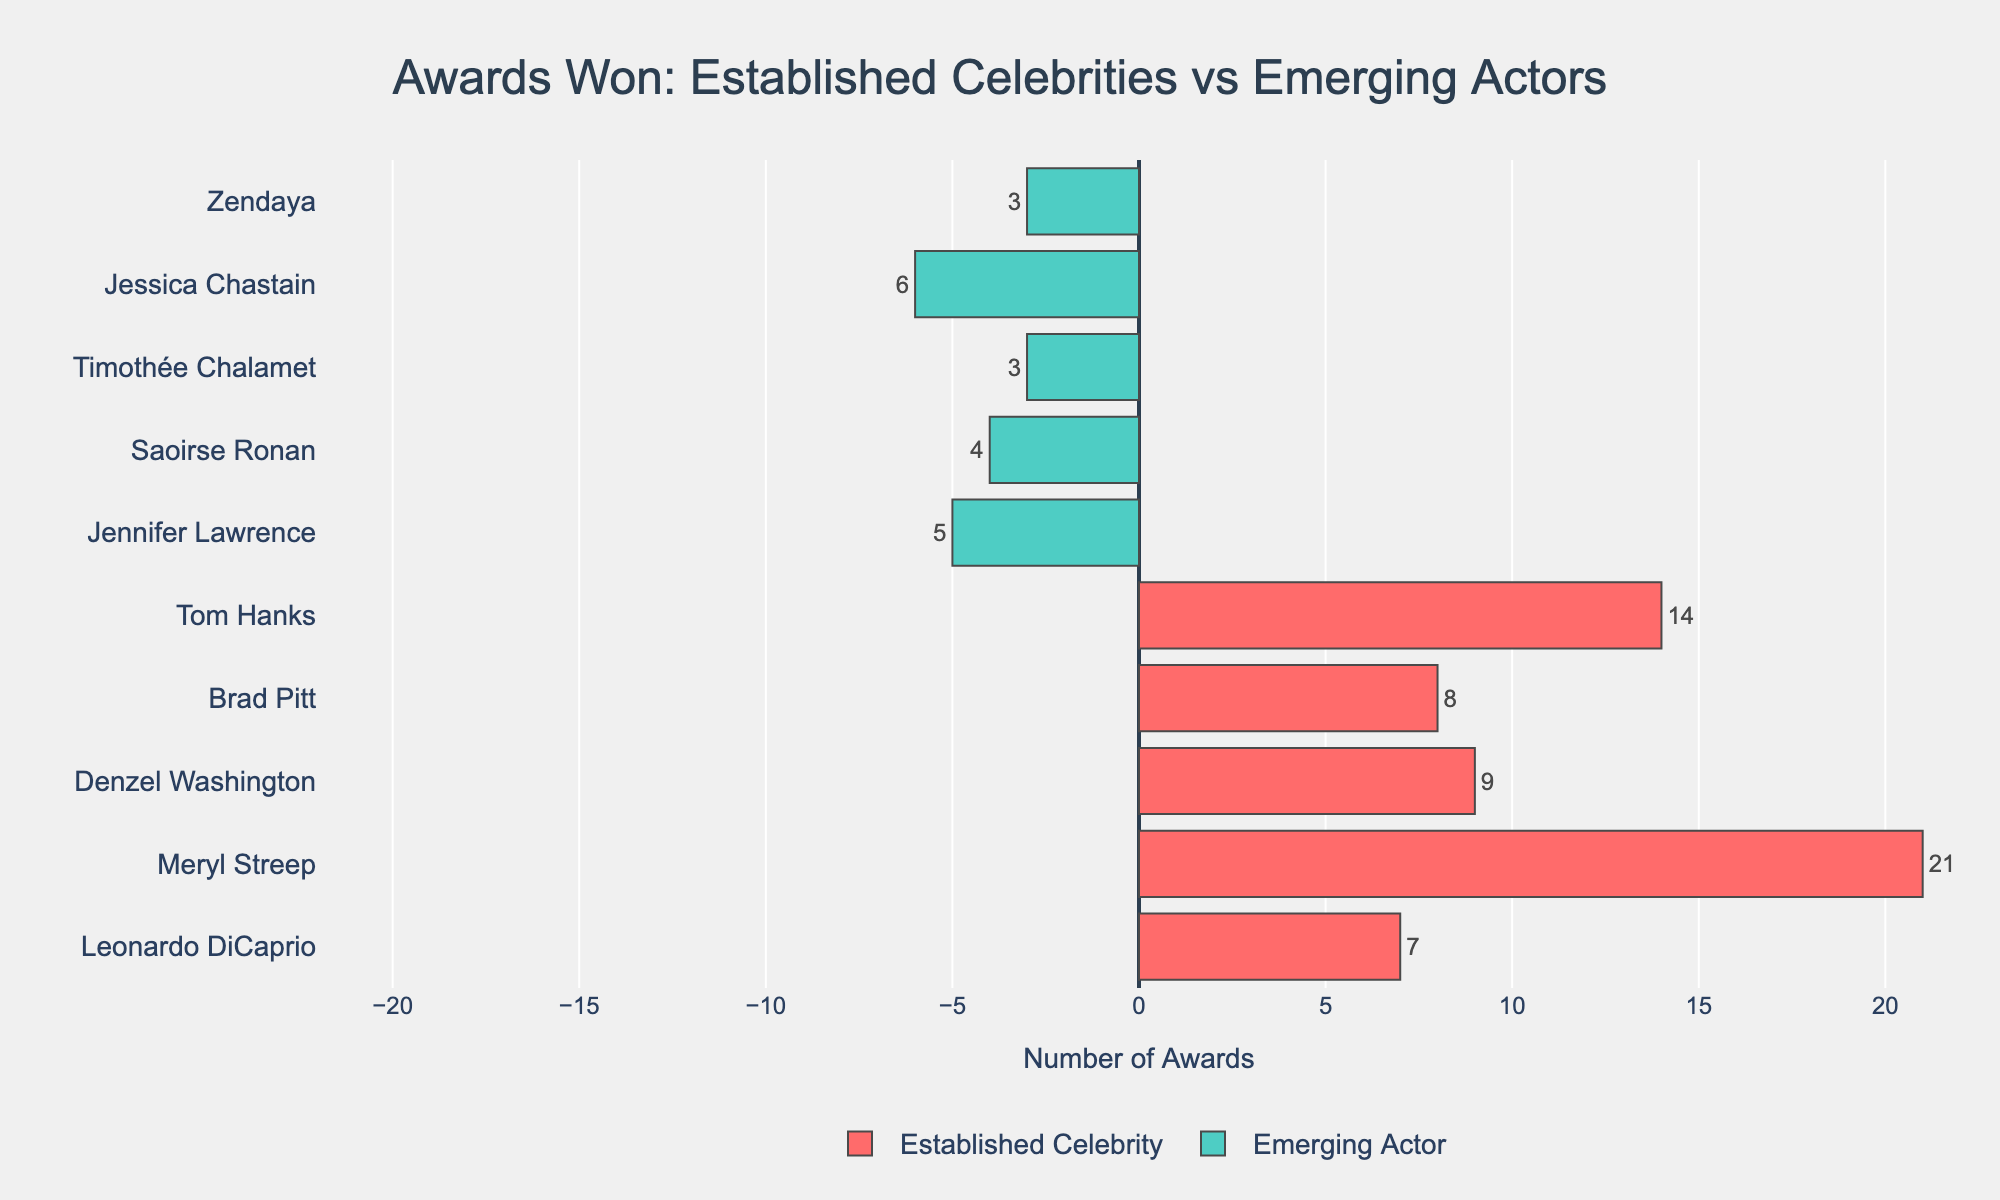Which established celebrity has won the most awards? Meryl Streep is at the top of the established celebrities' bars with 21 awards.
Answer: Meryl Streep How many more awards has Tom Hanks won compared to Jennifer Lawrence? Tom Hanks has 14 awards, and Jennifer Lawrence has 5 awards. The difference is 14 - 5.
Answer: 9 Who has won more awards, Brad Pitt or Jessica Chastain? Brad Pitt has won 8 awards, and Jessica Chastain has won 6 awards. 8 is greater than 6.
Answer: Brad Pitt Among the emerging actors, who has won the least awards? Both Timothée Chalamet and Zendaya are at the bottom among emerging actors with 3 awards each.
Answer: Timothée Chalamet and Zendaya What is the total number of awards won by all the established celebrities? Adding the awards of established celebrities: 7 (Leonardo DiCaprio) + 21 (Meryl Streep) + 9 (Denzel Washington) + 8 (Brad Pitt) + 14 (Tom Hanks) = 59
Answer: 59 Which category has a wider range of awards won, established celebrities or emerging actors? The range for established celebrities is 21 (max) - 7 (min) = 14. For emerging actors, it is 6 (max) - 3 (min) = 3. The range is wider for established celebrities.
Answer: Established Celebrities How do the awards won by Leonardo DiCaprio and Saoirse Ronan compare? Leonardo DiCaprio has 7 awards while Saoirse Ronan has 4 awards. 7 is greater than 4.
Answer: Leonardo DiCaprio has more What's the combined total of awards won by the emerging actors? Adding the awards won by emerging actors: 5 (Jennifer Lawrence) + 4 (Saoirse Ronan) + 3 (Timothée Chalamet) + 6 (Jessica Chastain) + 3 (Zendaya) = 21
Answer: 21 Is there an emerging actor who has won more awards than any established celebrity? The emerging actor with the most awards is Jessica Chastain with 6 awards, and the established celebrity with the fewest awards is Leonardo DiCaprio with 7. No emerging actor has more awards than the least awarded established celebrity.
Answer: No 